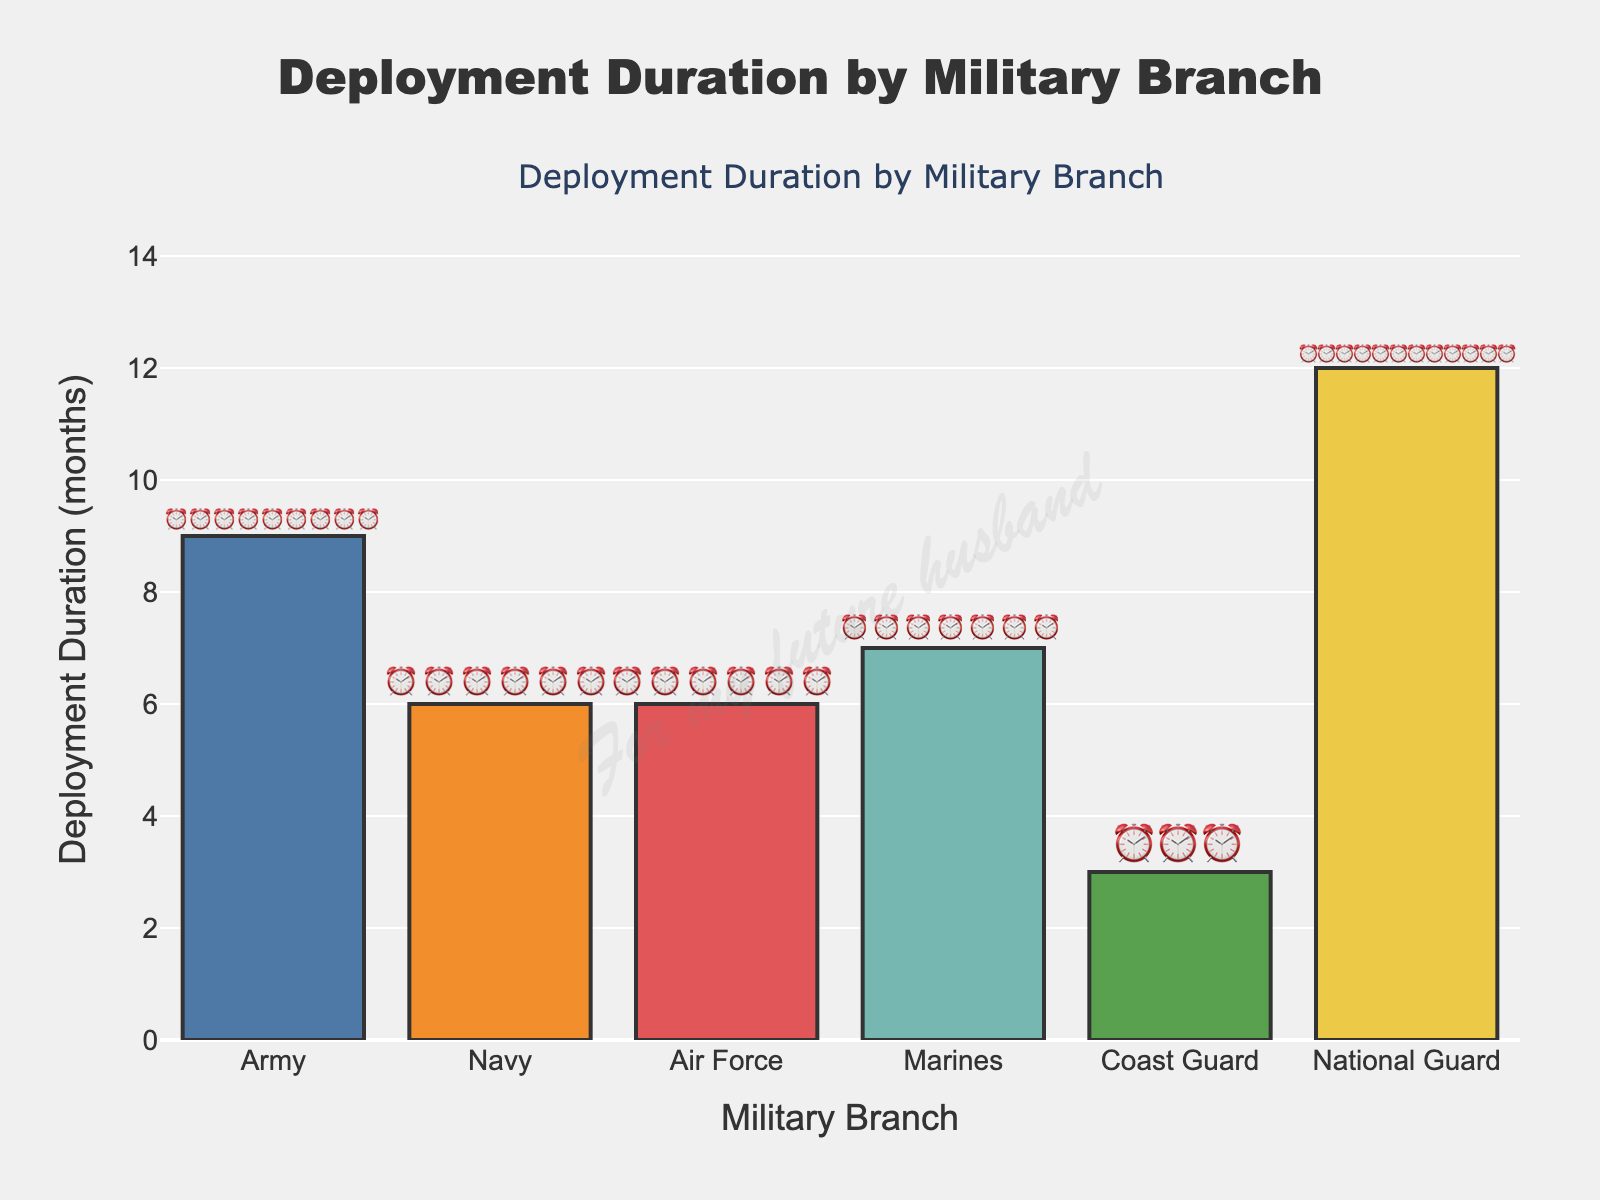Which military branch has the longest deployment duration? The data shows the number of months in the "Deployment Duration" for each branch, and the National Guard has 12 months, which is the highest value.
Answer: National Guard How many deployment months does the Navy have? Looking at the figure, the Navy has 6 clock emojis, indicating a 6-month deployment duration.
Answer: 6 months Compare the deployment durations of the Marines and the Air Force. Which one is longer? The figure shows the Marines with 7 clock emojis and the Air Force with 6 clock emojis. Since 7 is greater than 6, the Marines have a longer deployment duration than the Air Force.
Answer: Marines What is the average deployment duration across all listed branches? To find the average deployment duration, add up all deployment months and divide by the number of branches: (9+6+6+7+3+12) / 6 = 43 / 6.
Answer: 7.17 months (rounded to two decimal places) How much longer is the Army’s deployment compared to the Navy's? The Army's deployment duration is 9 months, while the Navy's is 6 months. Subtracting these gives 9 - 6.
Answer: 3 months What branch has the shortest deployment duration, and how many months is it? The figure shows the Coast Guard with 3 clock emojis, the least number of emojis indicating deployment months.
Answer: Coast Guard, 3 months If you combine the deployment durations of the Air Force and the Marines, what would the total be? Adding the deployment duration of the Air Force (6 months) and the Marines (7 months) gives a total duration of 6 + 7.
Answer: 13 months Are the deployment durations for the Navy and Air Force the same? The figure shows both the Navy and Air Force with 6 clock emojis each. Since both have the same number of clock emojis, their deployment durations are equal.
Answer: Yes How many branches have a deployment duration of 6 months? By counting the branches with 6 clock emojis in the figure, we see that the Navy and the Air Force each have 6 months. Therefore, there are 2 branches with a 6-month deployment.
Answer: 2 branches 